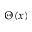Convert formula to latex. <formula><loc_0><loc_0><loc_500><loc_500>\Theta ( x )</formula> 